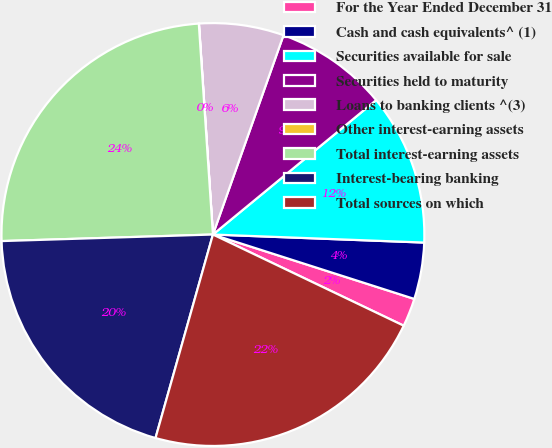Convert chart to OTSL. <chart><loc_0><loc_0><loc_500><loc_500><pie_chart><fcel>For the Year Ended December 31<fcel>Cash and cash equivalents^ (1)<fcel>Securities available for sale<fcel>Securities held to maturity<fcel>Loans to banking clients ^(3)<fcel>Other interest-earning assets<fcel>Total interest-earning assets<fcel>Interest-bearing banking<fcel>Total sources on which<nl><fcel>2.17%<fcel>4.32%<fcel>11.57%<fcel>8.62%<fcel>6.47%<fcel>0.01%<fcel>24.43%<fcel>20.13%<fcel>22.28%<nl></chart> 